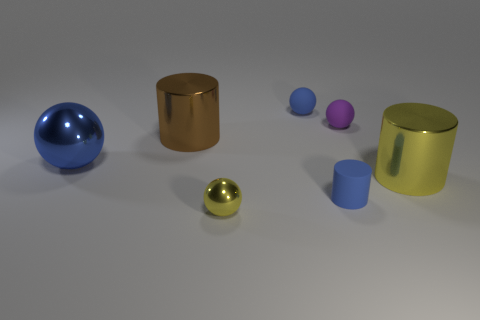Are there any other large objects that have the same shape as the large brown object?
Provide a short and direct response. Yes. What is the size of the yellow shiny thing behind the metallic object that is in front of the big yellow object?
Your response must be concise. Large. The metallic thing on the right side of the small blue object that is in front of the metal cylinder behind the big yellow thing is what shape?
Your response must be concise. Cylinder. What is the size of the yellow cylinder that is the same material as the big blue object?
Offer a very short reply. Large. Is the number of blue balls greater than the number of red shiny spheres?
Keep it short and to the point. Yes. What is the material of the other cylinder that is the same size as the yellow cylinder?
Offer a terse response. Metal. Is the size of the blue matte thing that is behind the yellow cylinder the same as the big blue ball?
Offer a very short reply. No. What number of cubes are brown things or big blue things?
Provide a succinct answer. 0. What material is the blue ball that is left of the yellow metallic sphere?
Provide a short and direct response. Metal. Are there fewer metallic things than blue rubber cylinders?
Make the answer very short. No. 